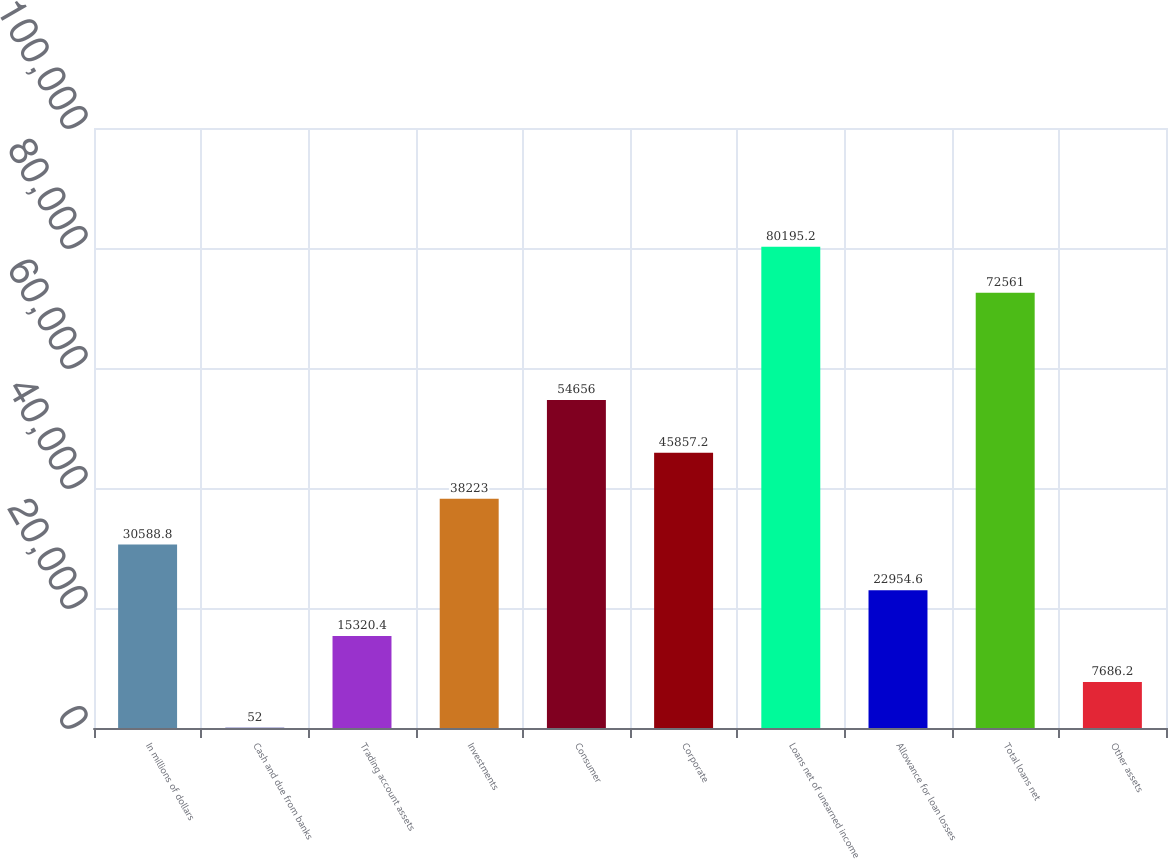Convert chart. <chart><loc_0><loc_0><loc_500><loc_500><bar_chart><fcel>In millions of dollars<fcel>Cash and due from banks<fcel>Trading account assets<fcel>Investments<fcel>Consumer<fcel>Corporate<fcel>Loans net of unearned income<fcel>Allowance for loan losses<fcel>Total loans net<fcel>Other assets<nl><fcel>30588.8<fcel>52<fcel>15320.4<fcel>38223<fcel>54656<fcel>45857.2<fcel>80195.2<fcel>22954.6<fcel>72561<fcel>7686.2<nl></chart> 